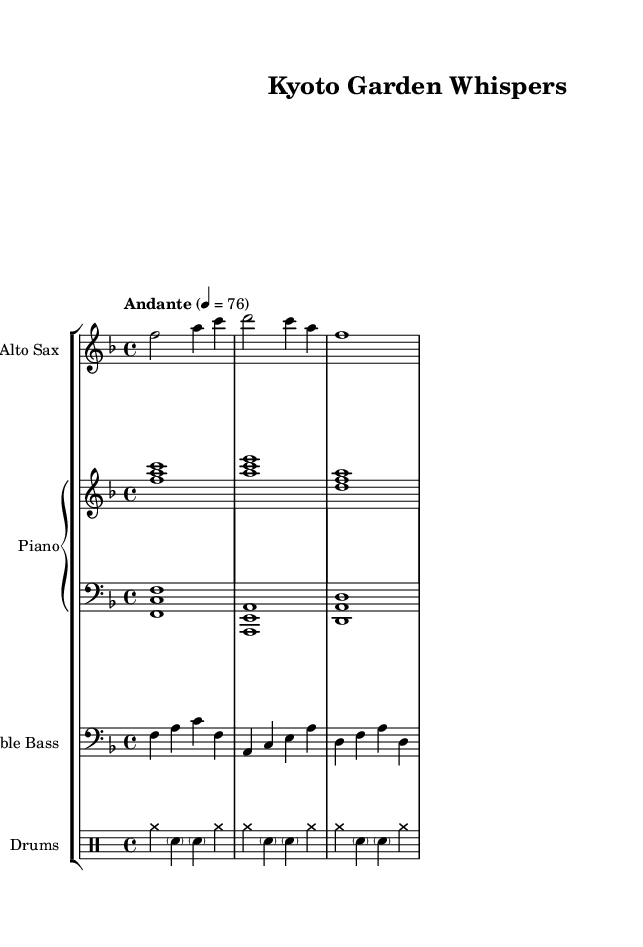What is the key signature of this music? The key signature is F major, which has one flat (B flat). You can tell by looking at the key signature indicator at the beginning of the staff.
Answer: F major What is the time signature of this piece? The time signature is 4/4, as indicated at the beginning of the score. You can identify this by the two numbers stacked above each other at the start of the staff.
Answer: 4/4 What is the tempo marking of this piece? The tempo marking is Andante, indicated in words at the beginning of the score, which suggests a moderate pace.
Answer: Andante How many measures are in the saxophone part? The saxophone part has three measures. You can count the vertical bar lines that separate each measure, indicating the number of musical sections.
Answer: Three What rhythmic style is used in the drum part? The drum part uses a swing style, typical in jazz interpretations, characterized by the use of cymbals and syncopated snare hits. This is inferred from the use of the cymbals and the specific rhythmic notation visible in the drums section.
Answer: Swing Which instrument plays the harmony alongside the saxophone? The piano plays the harmony alongside the saxophone, as indicated by its chordal structure written in the piano part above the saxophone line.
Answer: Piano What genre is this piece categorized under? This piece is categorized under smooth jazz, as indicated by the gentle rhythms and harmonies that evoke a tranquil atmosphere, reflective of the peaceful gardens of Kyoto.
Answer: Smooth Jazz 